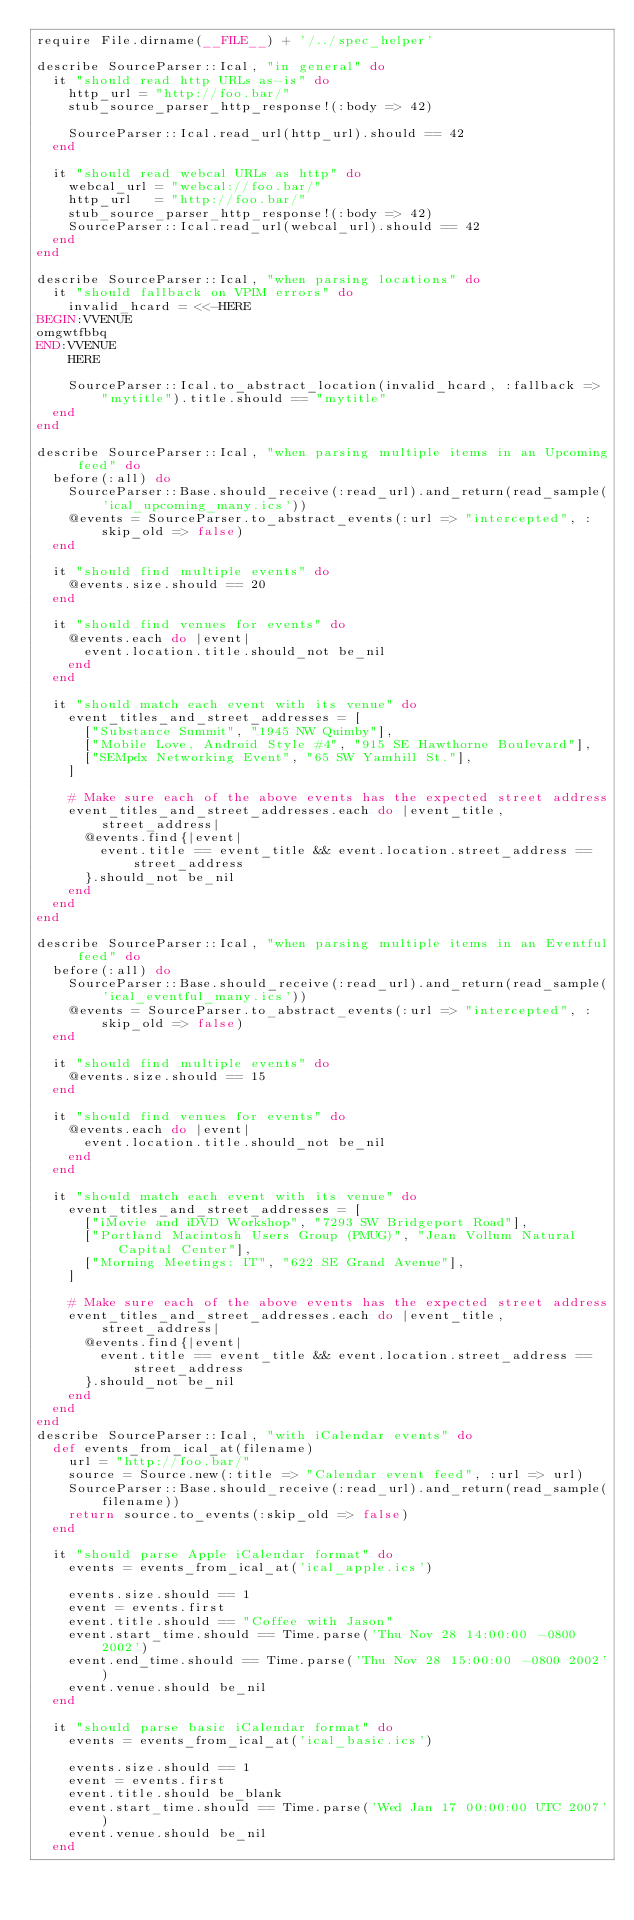Convert code to text. <code><loc_0><loc_0><loc_500><loc_500><_Ruby_>require File.dirname(__FILE__) + '/../spec_helper'

describe SourceParser::Ical, "in general" do
  it "should read http URLs as-is" do
    http_url = "http://foo.bar/"
    stub_source_parser_http_response!(:body => 42)

    SourceParser::Ical.read_url(http_url).should == 42
  end

  it "should read webcal URLs as http" do
    webcal_url = "webcal://foo.bar/"
    http_url   = "http://foo.bar/"
    stub_source_parser_http_response!(:body => 42)
    SourceParser::Ical.read_url(webcal_url).should == 42
  end
end

describe SourceParser::Ical, "when parsing locations" do
  it "should fallback on VPIM errors" do
    invalid_hcard = <<-HERE
BEGIN:VVENUE
omgwtfbbq
END:VVENUE
    HERE

    SourceParser::Ical.to_abstract_location(invalid_hcard, :fallback => "mytitle").title.should == "mytitle"
  end
end

describe SourceParser::Ical, "when parsing multiple items in an Upcoming feed" do
  before(:all) do
    SourceParser::Base.should_receive(:read_url).and_return(read_sample('ical_upcoming_many.ics'))
    @events = SourceParser.to_abstract_events(:url => "intercepted", :skip_old => false)
  end

  it "should find multiple events" do
    @events.size.should == 20
  end

  it "should find venues for events" do
    @events.each do |event|
      event.location.title.should_not be_nil
    end
  end

  it "should match each event with its venue" do
    event_titles_and_street_addresses = [
      ["Substance Summit", "1945 NW Quimby"],
      ["Mobile Love, Android Style #4", "915 SE Hawthorne Boulevard"],
      ["SEMpdx Networking Event", "65 SW Yamhill St."],
    ]

    # Make sure each of the above events has the expected street address
    event_titles_and_street_addresses.each do |event_title, street_address|
      @events.find{|event|
        event.title == event_title && event.location.street_address == street_address
      }.should_not be_nil
    end
  end
end

describe SourceParser::Ical, "when parsing multiple items in an Eventful feed" do
  before(:all) do
    SourceParser::Base.should_receive(:read_url).and_return(read_sample('ical_eventful_many.ics'))
    @events = SourceParser.to_abstract_events(:url => "intercepted", :skip_old => false)
  end

  it "should find multiple events" do
    @events.size.should == 15
  end

  it "should find venues for events" do
    @events.each do |event|
      event.location.title.should_not be_nil
    end
  end

  it "should match each event with its venue" do
    event_titles_and_street_addresses = [
      ["iMovie and iDVD Workshop", "7293 SW Bridgeport Road"],
      ["Portland Macintosh Users Group (PMUG)", "Jean Vollum Natural Capital Center"],
      ["Morning Meetings: IT", "622 SE Grand Avenue"],
    ]

    # Make sure each of the above events has the expected street address
    event_titles_and_street_addresses.each do |event_title, street_address|
      @events.find{|event|
        event.title == event_title && event.location.street_address == street_address
      }.should_not be_nil
    end
  end
end
describe SourceParser::Ical, "with iCalendar events" do
  def events_from_ical_at(filename)
    url = "http://foo.bar/"
    source = Source.new(:title => "Calendar event feed", :url => url)
    SourceParser::Base.should_receive(:read_url).and_return(read_sample(filename))
    return source.to_events(:skip_old => false)
  end

  it "should parse Apple iCalendar format" do
    events = events_from_ical_at('ical_apple.ics')

    events.size.should == 1
    event = events.first
    event.title.should == "Coffee with Jason"
    event.start_time.should == Time.parse('Thu Nov 28 14:00:00 -0800 2002')
    event.end_time.should == Time.parse('Thu Nov 28 15:00:00 -0800 2002')
    event.venue.should be_nil
  end

  it "should parse basic iCalendar format" do
    events = events_from_ical_at('ical_basic.ics')

    events.size.should == 1
    event = events.first
    event.title.should be_blank
    event.start_time.should == Time.parse('Wed Jan 17 00:00:00 UTC 2007')
    event.venue.should be_nil
  end
</code> 